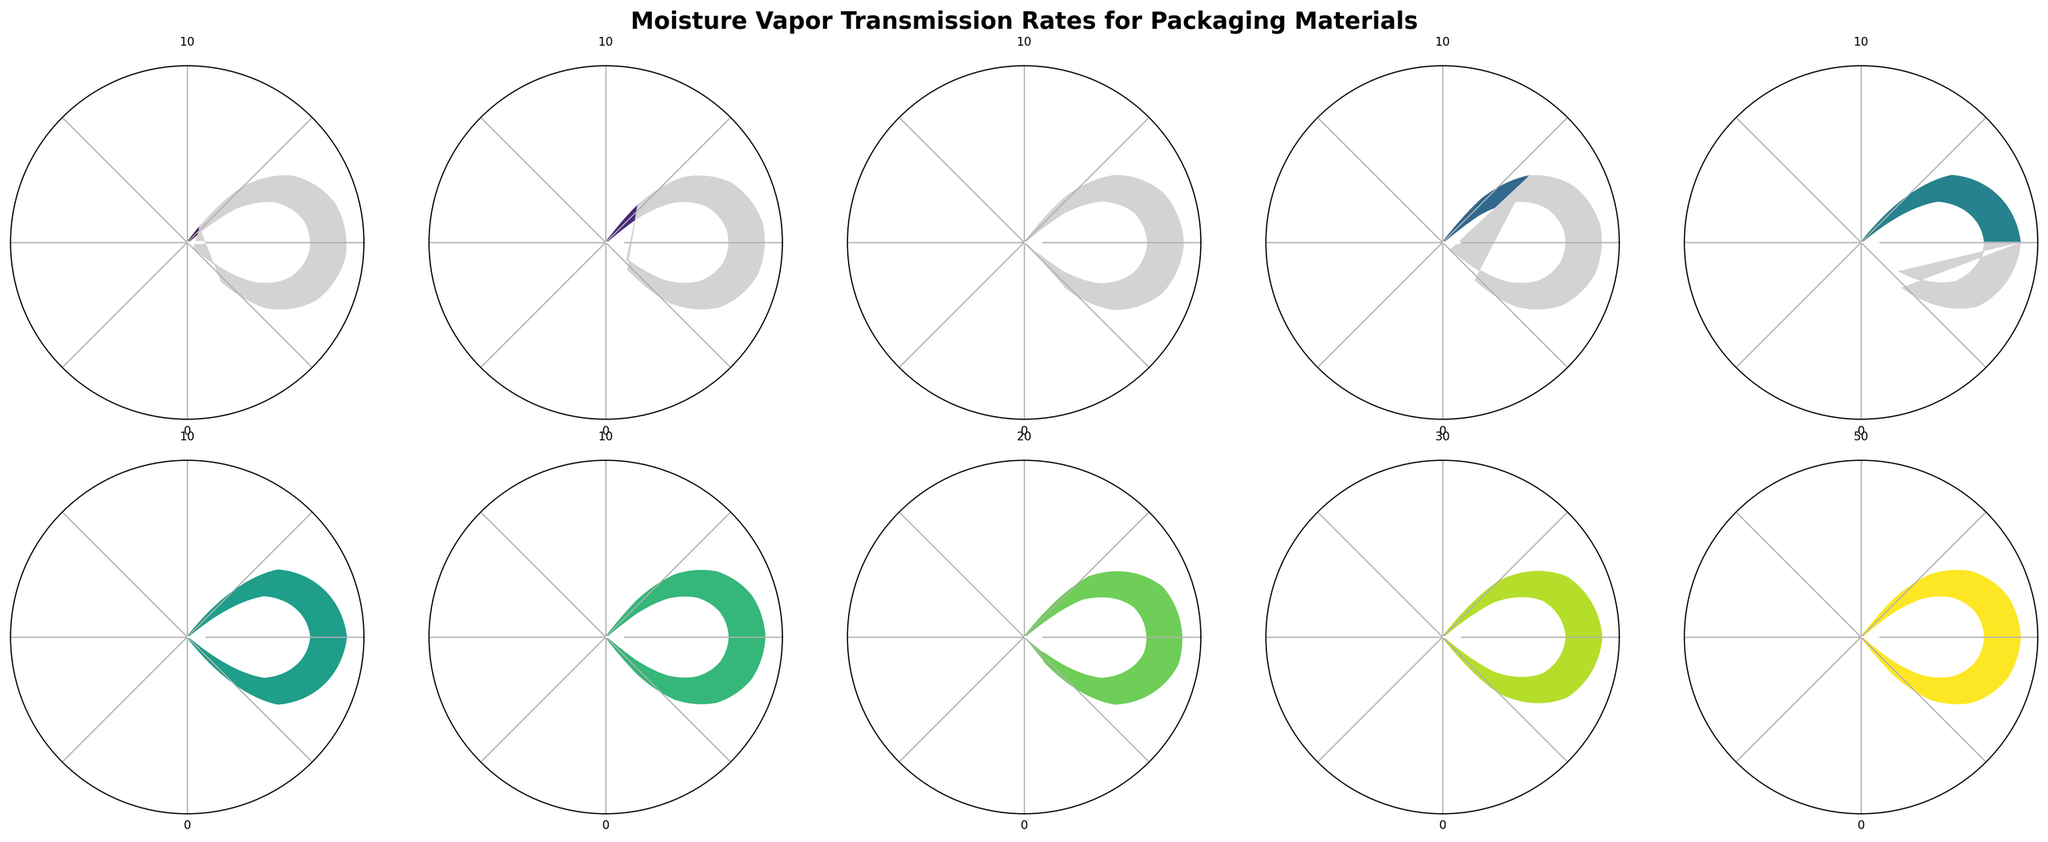What's the lowest MVTR value among the materials? The chart shows multiple materials with their MVTR values indicated by gauge arcs. The material with the smallest arc is Aluminum foil, marked with a value of 0.01 g/m²/day.
Answer: 0.01 g/m²/day What's the range of MVTR values for Kraft paper? The gauge for Kraft paper shows the range of MVTR values on its scale. The minimum value is 0, and the maximum value is 50 g/m²/day.
Answer: 0-50 g/m²/day Which material has the highest MVTR value depicted in the chart? By evaluating the arcs, Kraft paper has the longest arc reaching up to 40.0 g/m²/day, indicating that it has the highest MVTR value among the materials shown.
Answer: Kraft paper How do the MVTR values of LDPE and HDPE compare? Both arcs for LDPE and HDPE can be compared. LDPE shows an MVTR of 5.0 g/m²/day, while HDPE shows an MVTR of 2.5 g/m²/day. LDPE has a higher MVTR value.
Answer: LDPE > HDPE What's the difference in MVTR values between Cellophane and Nylon? Subtract the MVTR value of Cellophane (15.0 g/m²/day) from that of Nylon (20.0 g/m²/day): 20.0 - 15.0 = 5.0g/m²/day.
Answer: 5.0 g/m²/day Which materials have an MVTR value greater than 1 g/m²/day but less than 10 g/m²/day? Review the arcs and identify those materials whose MVTR values fall within the specified range: Metallized PET (1.2 g/m²/day), HDPE (2.5 g/m²/day), LDPE (5.0 g/m²/day), and PET (8.0 g/m²/day).
Answer: Metallized PET, HDPE, LDPE, PET How many materials have an MVTR value below 1 g/m²/day? Count the materials with arcs representing values below 1 g/m²/day: EVOH (0.2 g/m²/day), PVDC (0.5 g/m²/day), Aluminum foil (0.01 g/m²/day).
Answer: 3 What is the median MVTR value of the materials listed? First, list the MVTR values in ascending order: 0.01, 0.2, 0.5, 1.2, 2.5, 5.0, 8.0, 15.0, 20.0, 40.0. With an even number of entries (10), the median is the average of the 5th and 6th values: (2.5 + 5.0) / 2 = 3.75 g/m²/day.
Answer: 3.75 g/m²/day 